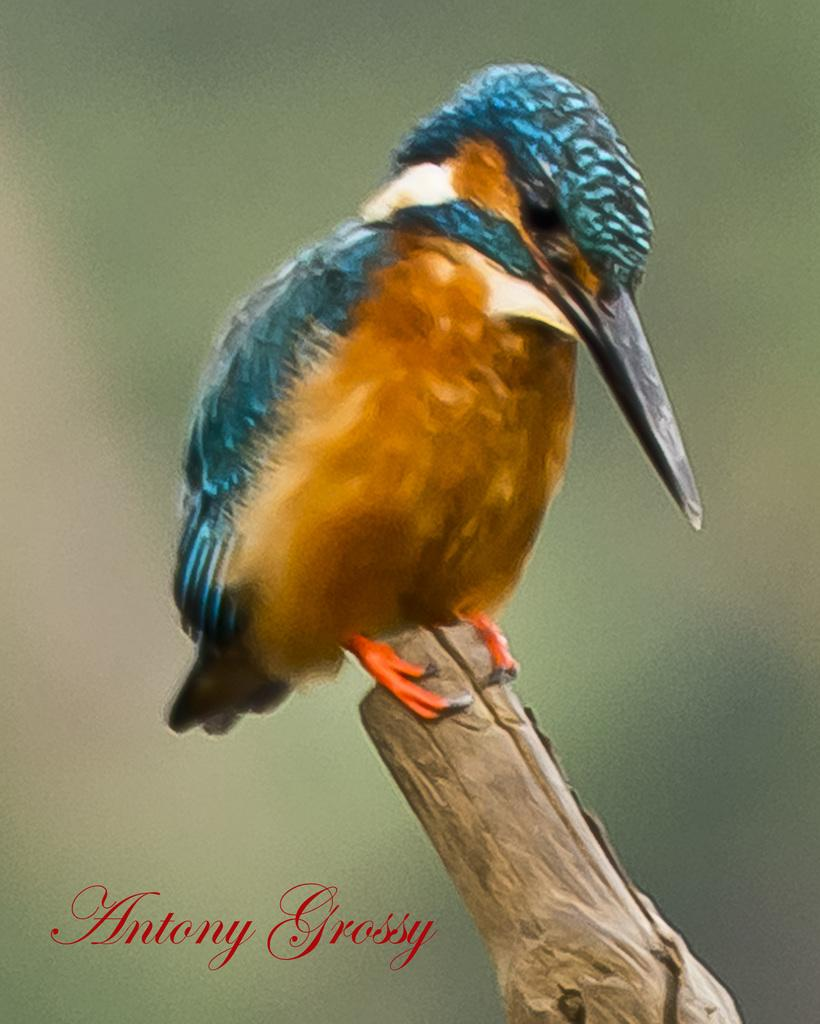What type of animal can be seen in the image? There is a bird in the image. Where is the bird located in the image? The bird is on a branch. How many brothers does the bird have in the image? There is no information about the bird's brothers in the image. What type of food is the bird eating in the image? There is no food visible in the image, so it cannot be determined what the bird might be eating. 